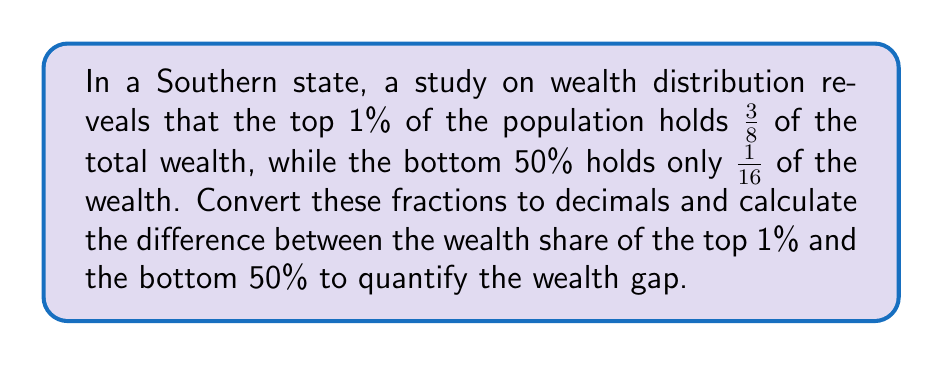Could you help me with this problem? To solve this problem, we need to convert the fractions to decimals and then find their difference. Let's break it down step-by-step:

1. Convert $\frac{3}{8}$ (wealth share of top 1%) to a decimal:
   $$\frac{3}{8} = 3 \div 8 = 0.375$$

2. Convert $\frac{1}{16}$ (wealth share of bottom 50%) to a decimal:
   $$\frac{1}{16} = 1 \div 16 = 0.0625$$

3. Calculate the difference between these two decimal values:
   $$0.375 - 0.0625 = 0.3125$$

This difference represents the wealth gap between the top 1% and the bottom 50% of the population in decimal form.

To express this as a percentage, we can multiply the result by 100:
$$0.3125 \times 100 = 31.25\%$$

This means that the top 1% of the population holds 31.25 percentage points more of the total wealth than the bottom 50% of the population.
Answer: The difference between the wealth share of the top 1% and the bottom 50% is 0.3125 or 31.25%. 